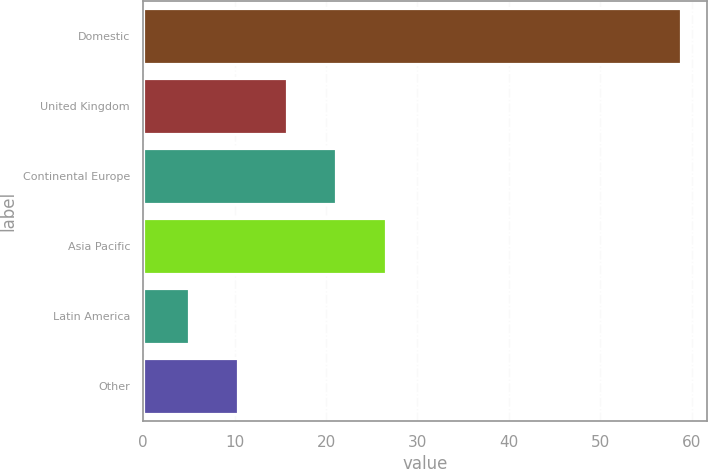Convert chart. <chart><loc_0><loc_0><loc_500><loc_500><bar_chart><fcel>Domestic<fcel>United Kingdom<fcel>Continental Europe<fcel>Asia Pacific<fcel>Latin America<fcel>Other<nl><fcel>58.8<fcel>15.76<fcel>21.14<fcel>26.52<fcel>5<fcel>10.38<nl></chart> 